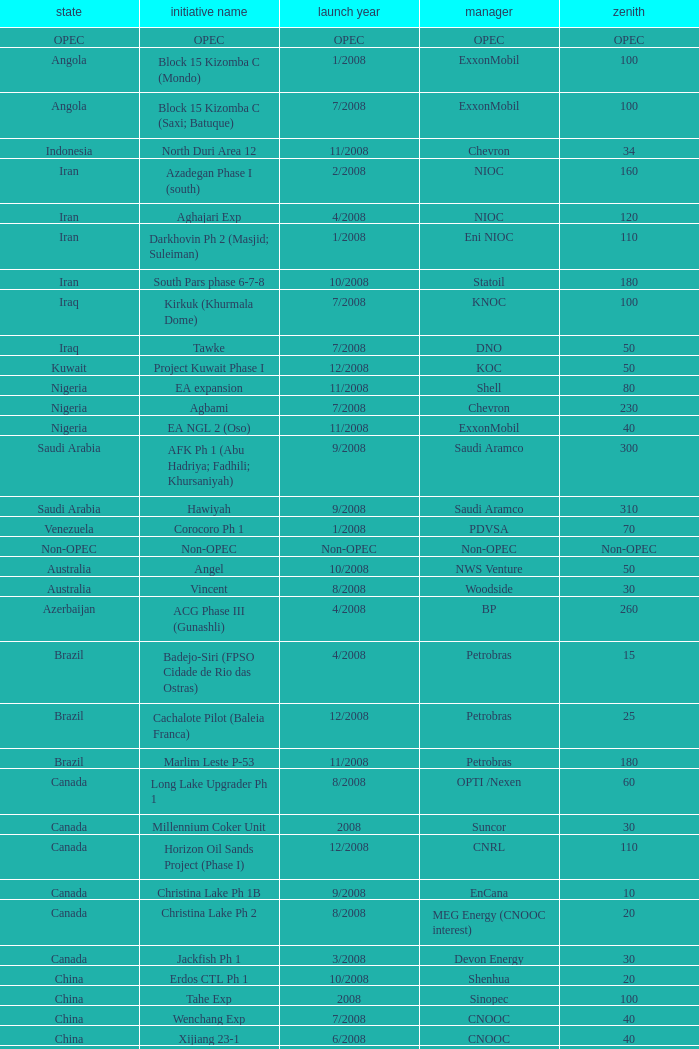What is the Peak with a Project Name that is talakan ph 1? 60.0. 